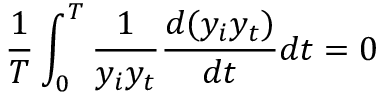Convert formula to latex. <formula><loc_0><loc_0><loc_500><loc_500>\frac { 1 } { T } \int _ { 0 } ^ { T } \frac { 1 } { y _ { i } y _ { t } } \frac { d ( y _ { i } y _ { t } ) } { d t } d t = 0</formula> 